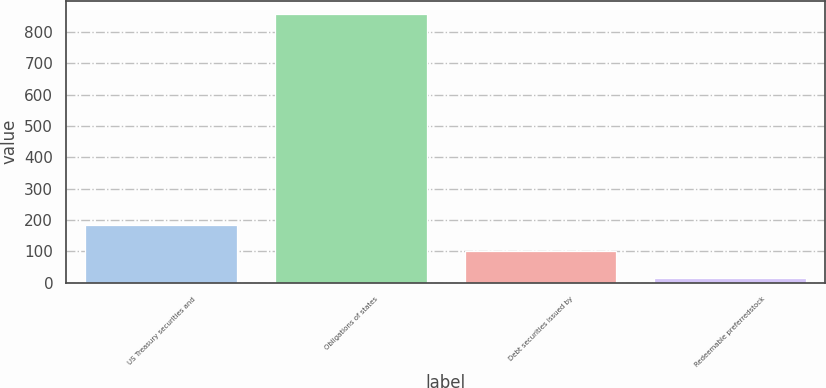<chart> <loc_0><loc_0><loc_500><loc_500><bar_chart><fcel>US Treasury securities and<fcel>Obligations of states<fcel>Debt securities issued by<fcel>Redeemable preferredstock<nl><fcel>184.2<fcel>857<fcel>100.1<fcel>16<nl></chart> 